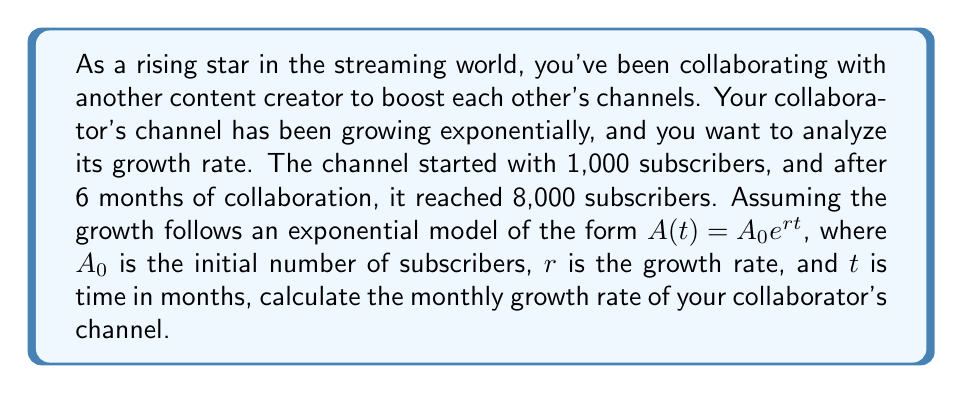Help me with this question. To solve this problem, we'll use the exponential growth model:

$$A(t) = A_0 e^{rt}$$

Where:
$A(t)$ is the number of subscribers at time $t$
$A_0$ is the initial number of subscribers
$r$ is the monthly growth rate
$t$ is the time in months

We know:
$A_0 = 1,000$ (initial subscribers)
$A(6) = 8,000$ (subscribers after 6 months)
$t = 6$ months

Let's substitute these values into the equation:

$$8,000 = 1,000 e^{r(6)}$$

Divide both sides by 1,000:

$$8 = e^{6r}$$

Take the natural logarithm of both sides:

$$\ln(8) = 6r$$

Solve for $r$:

$$r = \frac{\ln(8)}{6}$$

$$r = \frac{2.0794}{6}$$

$$r \approx 0.3466$$

To express this as a percentage, multiply by 100:

$$r \approx 34.66\%$$

This means the channel is growing at approximately 34.66% per month.
Answer: The monthly growth rate of your collaborator's channel is approximately 34.66%. 